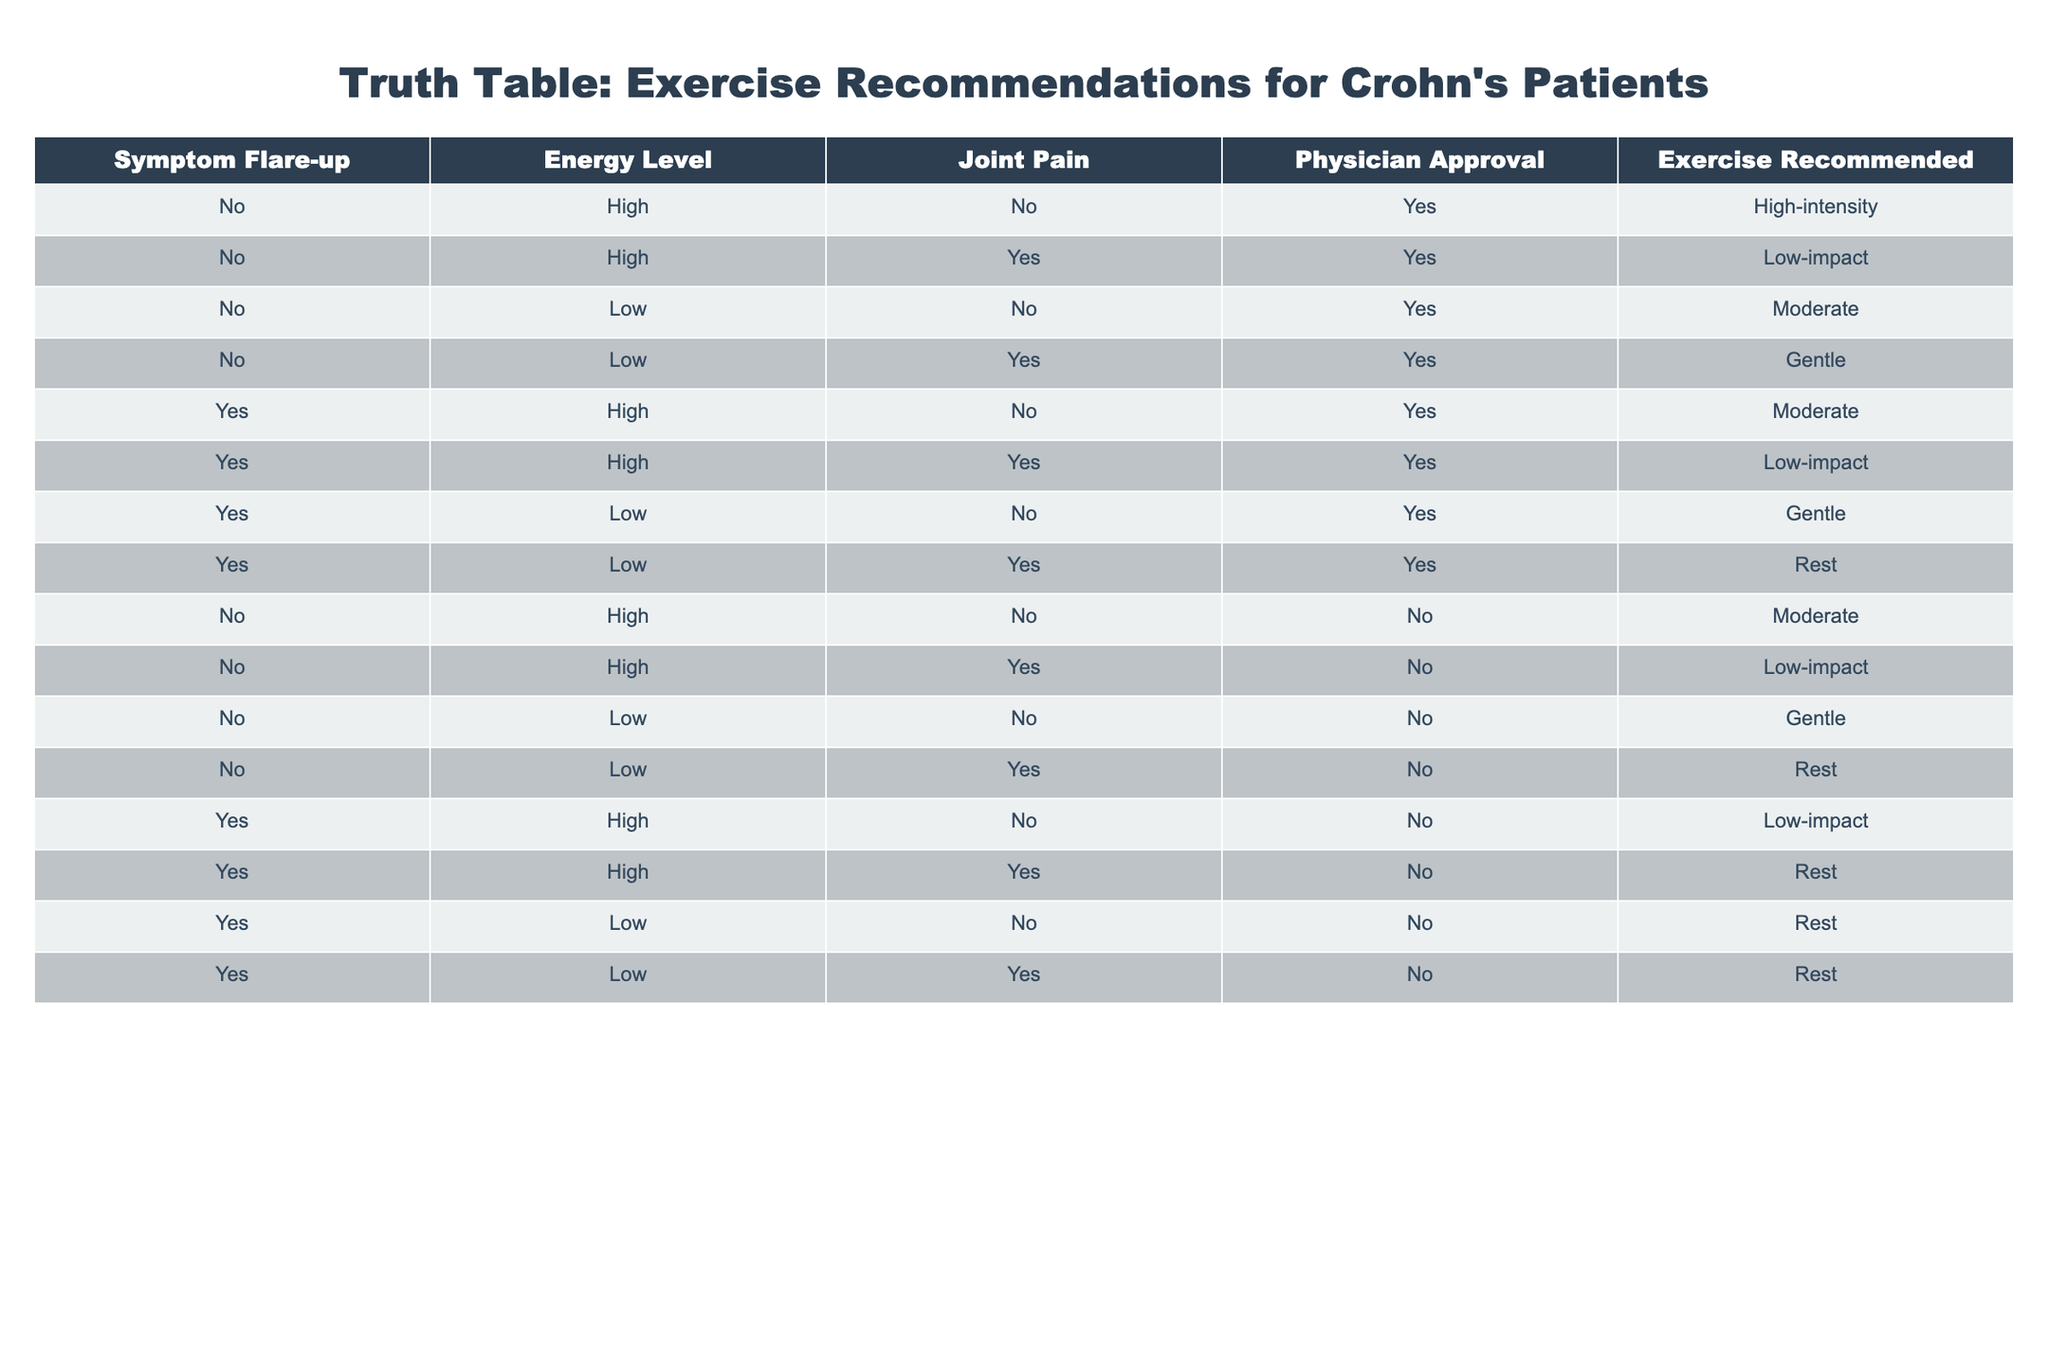What exercise is recommended when there is a symptom flare-up and high energy level? According to the table, when there is a symptom flare-up ("Yes") and a high energy level ("High"), the recommended exercise is "Moderate".
Answer: Moderate How many recommendations suggest low-impact exercise? By examining the table, the recommendations for low-impact exercise are found in the second and tenth rows, so there are a total of 2 recommendations that suggest low-impact exercises.
Answer: 2 Is moderate exercise recommended if there is a symptom flare-up but physician approval is not present? In the table, all instances where there is a symptom flare-up ("Yes") and no physician approval ("No") result in "Rest" as the recommendation. Thus, moderate exercise is not recommended under these conditions.
Answer: No What is the recommended exercise for a patient with low energy and no joint pain, given physician approval? Referring to the table, a patient with "Low" energy, "No" joint pain, and "Yes" for physician approval is indicated in the third row, which recommends "Moderate" exercise.
Answer: Moderate What is the average recommended exercise intensity for cases with a symptom flare-up? We examine the rows where "Yes" for symptom flare-up appears, which include moderate, low-impact, gentle, and rest recommendations. To assign numerical values for averaging: High-intensity (4), Moderate (3), Low-impact (2), Gentle (1), and Rest (0). Given the instances: Moderate (3), Low-impact (2), Gentle (1), Rest (0) totals to (3*2 + 2*2 + 1*2 + 0*2) = 6, so there are 6 instances in total, hence the average is 6/6 = 1. Average intensity level comes out to be about 1, corresponding to Gentle exercises overall.
Answer: Gentle Considering energy levels and physician approval, what types of exercises are recommended for patients in different energy conditions (low or high)? Looking at the table, for patients with "High" energy, recommended exercises can be "High-intensity", "Low-impact", and "Moderate" depending on joint pain and physician approval. For those with "Low" energy, recommendations vary from "Moderate", "Gentle", and "Rest" based on the presence of joint pain and physician approval status. This indicates that high energy allows for more diverse exercise types while low energy often leads to gentler or rest-based recommendations.
Answer: High: High-intensity, Low-impact, Moderate; Low: Moderate, Gentle, Rest 